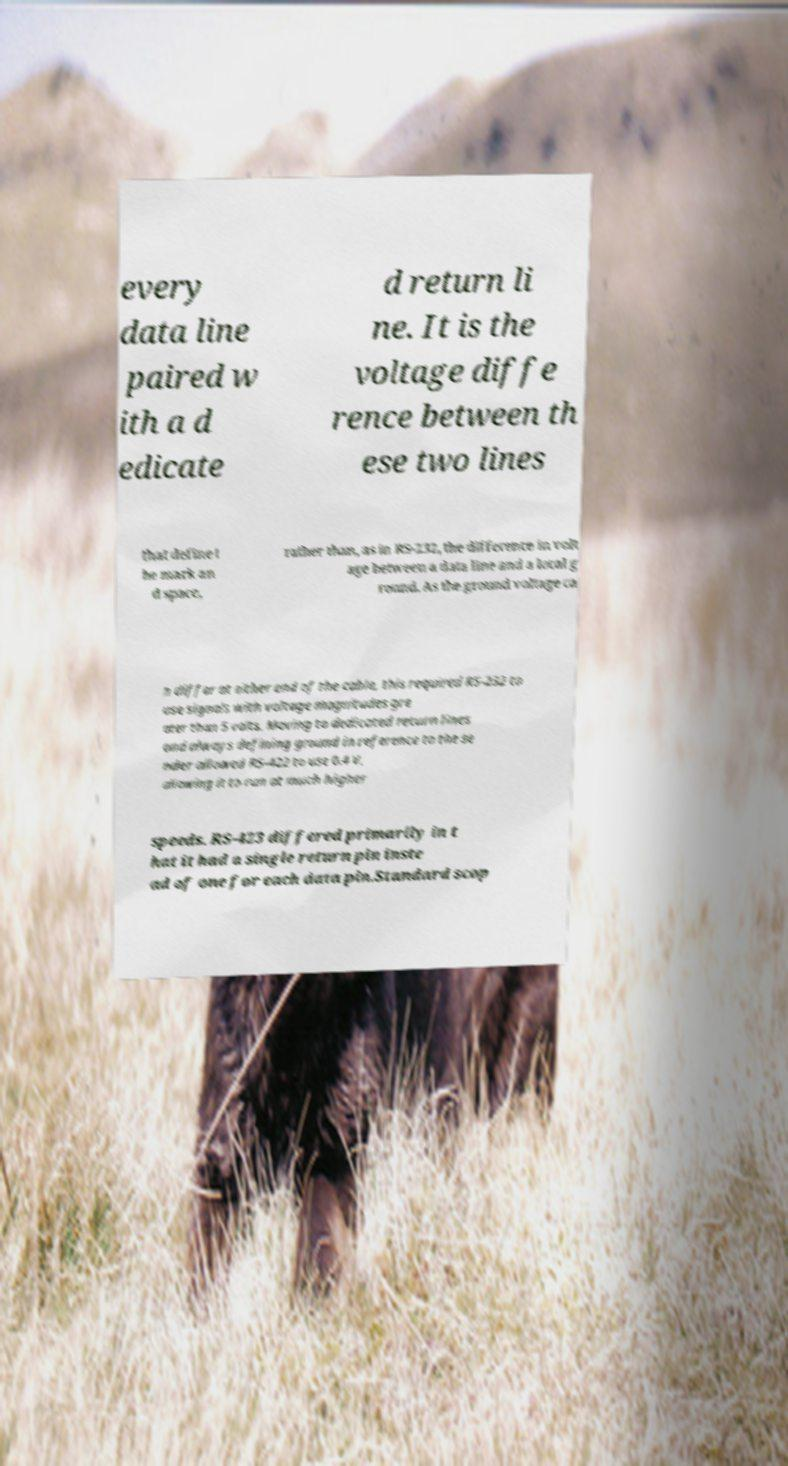What messages or text are displayed in this image? I need them in a readable, typed format. every data line paired w ith a d edicate d return li ne. It is the voltage diffe rence between th ese two lines that define t he mark an d space, rather than, as in RS-232, the difference in volt age between a data line and a local g round. As the ground voltage ca n differ at either end of the cable, this required RS-232 to use signals with voltage magnitudes gre ater than 5 volts. Moving to dedicated return lines and always defining ground in reference to the se nder allowed RS-422 to use 0.4 V, allowing it to run at much higher speeds. RS-423 differed primarily in t hat it had a single return pin inste ad of one for each data pin.Standard scop 